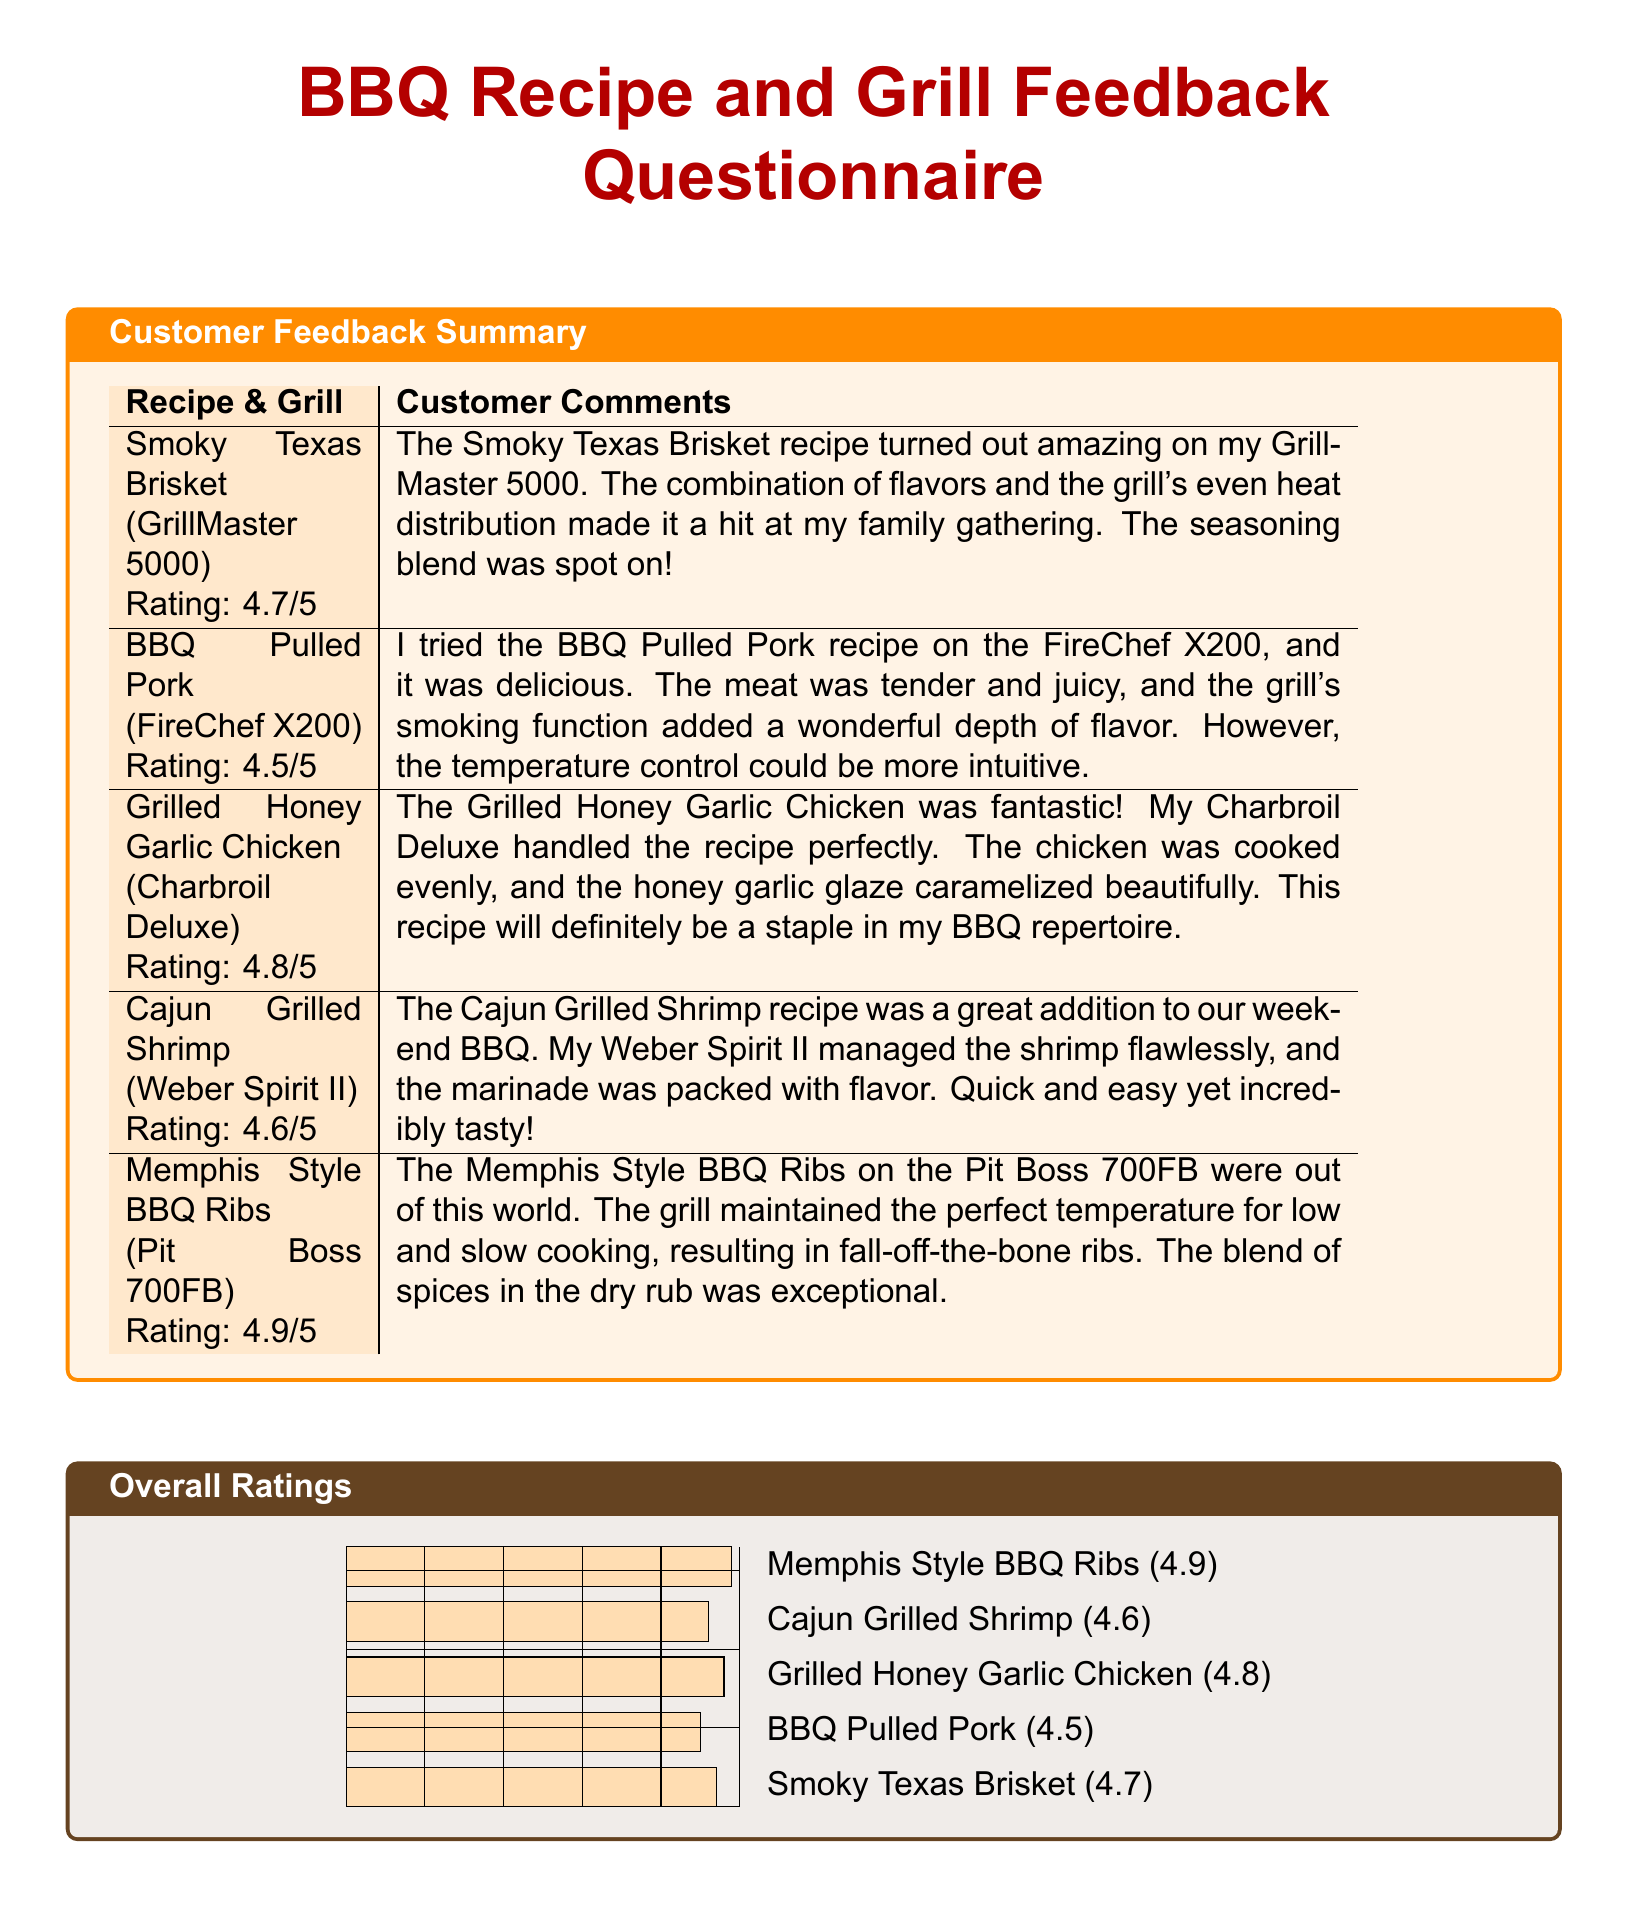What is the rating of Smoky Texas Brisket? The rating for Smoky Texas Brisket is stated in the document as 4.7 out of 5.
Answer: 4.7/5 What grill was used for BBQ Pulled Pork? The document specifies that the BBQ Pulled Pork was made using the FireChef X200 grill.
Answer: FireChef X200 Which recipe received the highest rating? By comparing the ratings of each recipe listed, the Memphis Style BBQ Ribs has the highest rating of 4.9 out of 5.
Answer: Memphis Style BBQ Ribs How many recipes are reviewed in the document? The document lists a total of five BBQ recipes with their corresponding grills and ratings.
Answer: Five What grill did the Grilled Honey Garlic Chicken use? The document indicates that the Grilled Honey Garlic Chicken was prepared on the Charbroil Deluxe grill.
Answer: Charbroil Deluxe Was the temperature control for BBQ Pulled Pork rated positively? The customer comment mentions that the temperature control could be more intuitive, indicating a negative aspect.
Answer: No What is the overall rating for Cajun Grilled Shrimp? The document specifies that the Cajun Grilled Shrimp recipe received a rating of 4.6 out of 5.
Answer: 4.6/5 Which recipe had a customer comment about the glaze? The customer feedback for Grilled Honey Garlic Chicken mentions the caramelization of the honey garlic glaze.
Answer: Grilled Honey Garlic Chicken What type of recipe is noted for its "fall-off-the-bone" quality? The Memphis Style BBQ Ribs are described in the comments as having fall-off-the-bone quality due to the cooking method used.
Answer: Memphis Style BBQ Ribs 